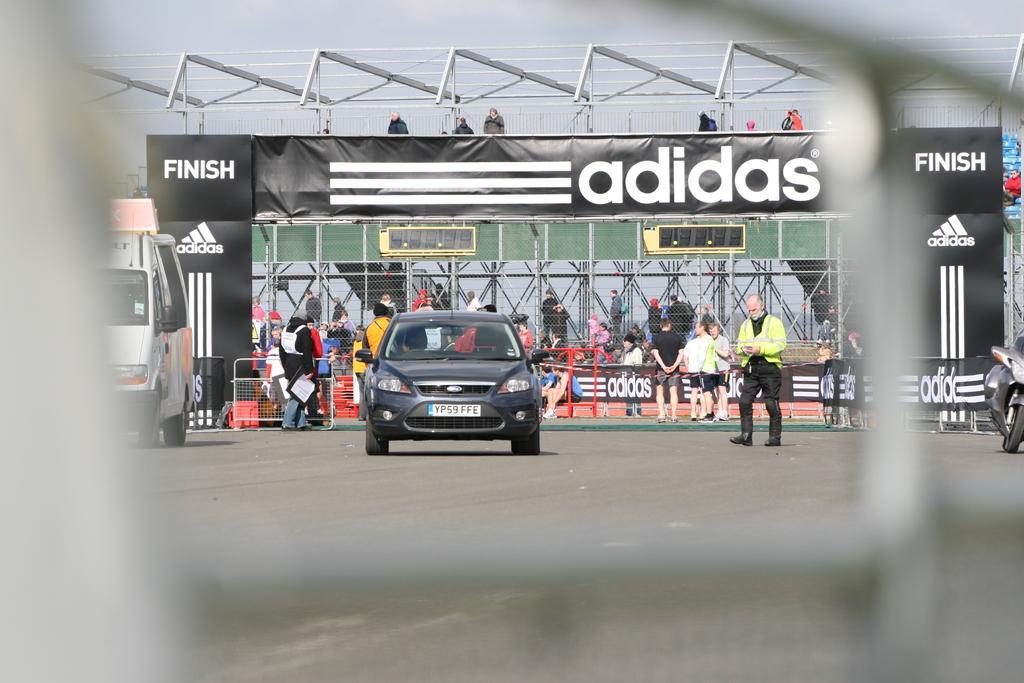How would you summarize this image in a sentence or two? This image is taken outdoors. In this image there is a mesh. At the bottom of the image there is a road. In the middle of the image a car is parked on the road. On the left side of the image a truck is parked on the ground. At the top of the image there is a sky. In the background there is a dais, a few boards and a text on them. There are many iron bars and grills. A few people are standing on the road and a few are sitting on the benches. 